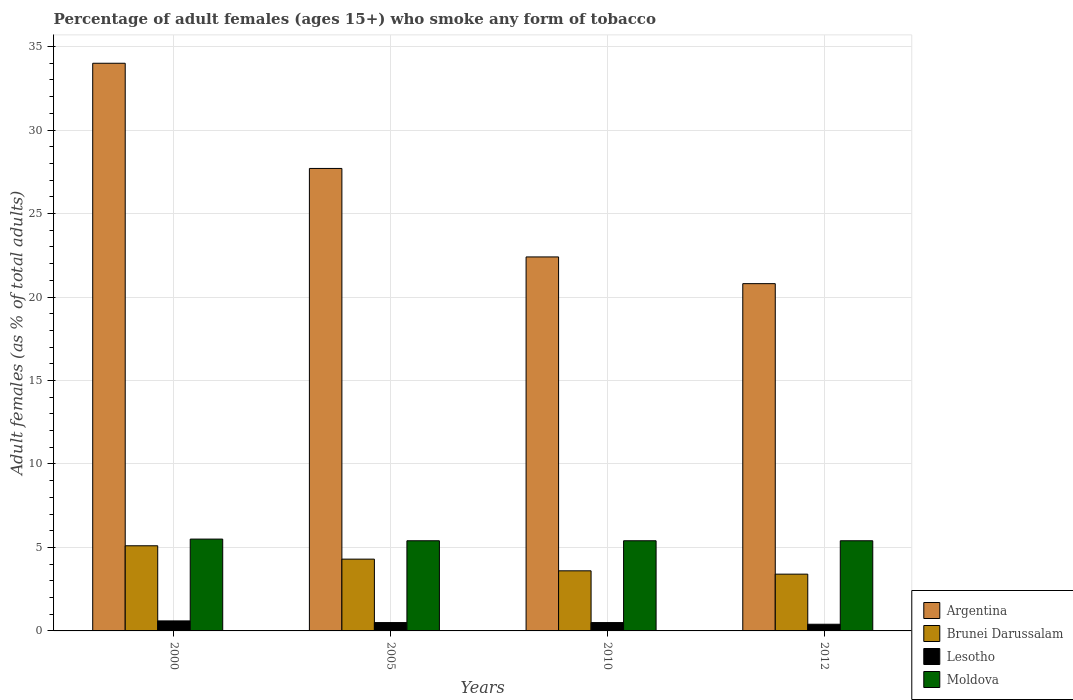How many groups of bars are there?
Give a very brief answer. 4. How many bars are there on the 4th tick from the left?
Provide a succinct answer. 4. How many bars are there on the 3rd tick from the right?
Your answer should be very brief. 4. What is the label of the 1st group of bars from the left?
Your answer should be compact. 2000. In how many cases, is the number of bars for a given year not equal to the number of legend labels?
Offer a very short reply. 0. What is the percentage of adult females who smoke in Argentina in 2012?
Give a very brief answer. 20.8. In which year was the percentage of adult females who smoke in Argentina maximum?
Your answer should be compact. 2000. What is the total percentage of adult females who smoke in Lesotho in the graph?
Provide a short and direct response. 2. What is the difference between the percentage of adult females who smoke in Brunei Darussalam in 2000 and that in 2010?
Your answer should be compact. 1.5. What is the difference between the percentage of adult females who smoke in Argentina in 2010 and the percentage of adult females who smoke in Lesotho in 2005?
Your answer should be compact. 21.9. What is the average percentage of adult females who smoke in Brunei Darussalam per year?
Provide a succinct answer. 4.1. In the year 2000, what is the difference between the percentage of adult females who smoke in Argentina and percentage of adult females who smoke in Brunei Darussalam?
Your response must be concise. 28.9. In how many years, is the percentage of adult females who smoke in Brunei Darussalam greater than 11 %?
Your answer should be very brief. 0. What is the ratio of the percentage of adult females who smoke in Brunei Darussalam in 2000 to that in 2010?
Provide a succinct answer. 1.42. Is the percentage of adult females who smoke in Lesotho in 2005 less than that in 2010?
Give a very brief answer. No. Is the difference between the percentage of adult females who smoke in Argentina in 2005 and 2012 greater than the difference between the percentage of adult females who smoke in Brunei Darussalam in 2005 and 2012?
Offer a very short reply. Yes. What is the difference between the highest and the second highest percentage of adult females who smoke in Lesotho?
Make the answer very short. 0.1. What is the difference between the highest and the lowest percentage of adult females who smoke in Brunei Darussalam?
Provide a short and direct response. 1.7. Is it the case that in every year, the sum of the percentage of adult females who smoke in Moldova and percentage of adult females who smoke in Brunei Darussalam is greater than the sum of percentage of adult females who smoke in Lesotho and percentage of adult females who smoke in Argentina?
Make the answer very short. Yes. What does the 2nd bar from the left in 2005 represents?
Offer a very short reply. Brunei Darussalam. What does the 2nd bar from the right in 2005 represents?
Offer a terse response. Lesotho. Is it the case that in every year, the sum of the percentage of adult females who smoke in Argentina and percentage of adult females who smoke in Moldova is greater than the percentage of adult females who smoke in Lesotho?
Offer a terse response. Yes. How many years are there in the graph?
Keep it short and to the point. 4. Does the graph contain any zero values?
Keep it short and to the point. No. Does the graph contain grids?
Provide a succinct answer. Yes. Where does the legend appear in the graph?
Your answer should be very brief. Bottom right. How are the legend labels stacked?
Your answer should be very brief. Vertical. What is the title of the graph?
Ensure brevity in your answer.  Percentage of adult females (ages 15+) who smoke any form of tobacco. What is the label or title of the Y-axis?
Offer a very short reply. Adult females (as % of total adults). What is the Adult females (as % of total adults) of Argentina in 2005?
Provide a short and direct response. 27.7. What is the Adult females (as % of total adults) in Argentina in 2010?
Your response must be concise. 22.4. What is the Adult females (as % of total adults) in Brunei Darussalam in 2010?
Your answer should be very brief. 3.6. What is the Adult females (as % of total adults) of Argentina in 2012?
Offer a very short reply. 20.8. Across all years, what is the maximum Adult females (as % of total adults) in Argentina?
Provide a succinct answer. 34. Across all years, what is the maximum Adult females (as % of total adults) in Brunei Darussalam?
Offer a very short reply. 5.1. Across all years, what is the maximum Adult females (as % of total adults) of Moldova?
Offer a terse response. 5.5. Across all years, what is the minimum Adult females (as % of total adults) of Argentina?
Make the answer very short. 20.8. Across all years, what is the minimum Adult females (as % of total adults) in Brunei Darussalam?
Make the answer very short. 3.4. Across all years, what is the minimum Adult females (as % of total adults) of Lesotho?
Give a very brief answer. 0.4. Across all years, what is the minimum Adult females (as % of total adults) in Moldova?
Ensure brevity in your answer.  5.4. What is the total Adult females (as % of total adults) in Argentina in the graph?
Make the answer very short. 104.9. What is the total Adult females (as % of total adults) of Brunei Darussalam in the graph?
Offer a terse response. 16.4. What is the total Adult females (as % of total adults) of Moldova in the graph?
Provide a short and direct response. 21.7. What is the difference between the Adult females (as % of total adults) of Argentina in 2000 and that in 2005?
Offer a terse response. 6.3. What is the difference between the Adult females (as % of total adults) of Argentina in 2000 and that in 2010?
Your response must be concise. 11.6. What is the difference between the Adult females (as % of total adults) of Brunei Darussalam in 2000 and that in 2010?
Offer a terse response. 1.5. What is the difference between the Adult females (as % of total adults) of Lesotho in 2000 and that in 2012?
Your response must be concise. 0.2. What is the difference between the Adult females (as % of total adults) of Moldova in 2000 and that in 2012?
Make the answer very short. 0.1. What is the difference between the Adult females (as % of total adults) in Brunei Darussalam in 2005 and that in 2010?
Offer a very short reply. 0.7. What is the difference between the Adult females (as % of total adults) of Lesotho in 2005 and that in 2010?
Your answer should be compact. 0. What is the difference between the Adult females (as % of total adults) of Brunei Darussalam in 2005 and that in 2012?
Make the answer very short. 0.9. What is the difference between the Adult females (as % of total adults) in Moldova in 2005 and that in 2012?
Give a very brief answer. 0. What is the difference between the Adult females (as % of total adults) of Brunei Darussalam in 2010 and that in 2012?
Offer a very short reply. 0.2. What is the difference between the Adult females (as % of total adults) in Lesotho in 2010 and that in 2012?
Ensure brevity in your answer.  0.1. What is the difference between the Adult females (as % of total adults) of Argentina in 2000 and the Adult females (as % of total adults) of Brunei Darussalam in 2005?
Keep it short and to the point. 29.7. What is the difference between the Adult females (as % of total adults) of Argentina in 2000 and the Adult females (as % of total adults) of Lesotho in 2005?
Give a very brief answer. 33.5. What is the difference between the Adult females (as % of total adults) of Argentina in 2000 and the Adult females (as % of total adults) of Moldova in 2005?
Offer a terse response. 28.6. What is the difference between the Adult females (as % of total adults) in Brunei Darussalam in 2000 and the Adult females (as % of total adults) in Lesotho in 2005?
Ensure brevity in your answer.  4.6. What is the difference between the Adult females (as % of total adults) in Brunei Darussalam in 2000 and the Adult females (as % of total adults) in Moldova in 2005?
Offer a terse response. -0.3. What is the difference between the Adult females (as % of total adults) in Argentina in 2000 and the Adult females (as % of total adults) in Brunei Darussalam in 2010?
Provide a succinct answer. 30.4. What is the difference between the Adult females (as % of total adults) of Argentina in 2000 and the Adult females (as % of total adults) of Lesotho in 2010?
Your response must be concise. 33.5. What is the difference between the Adult females (as % of total adults) of Argentina in 2000 and the Adult females (as % of total adults) of Moldova in 2010?
Make the answer very short. 28.6. What is the difference between the Adult females (as % of total adults) of Brunei Darussalam in 2000 and the Adult females (as % of total adults) of Lesotho in 2010?
Your answer should be very brief. 4.6. What is the difference between the Adult females (as % of total adults) of Argentina in 2000 and the Adult females (as % of total adults) of Brunei Darussalam in 2012?
Your response must be concise. 30.6. What is the difference between the Adult females (as % of total adults) in Argentina in 2000 and the Adult females (as % of total adults) in Lesotho in 2012?
Provide a short and direct response. 33.6. What is the difference between the Adult females (as % of total adults) of Argentina in 2000 and the Adult females (as % of total adults) of Moldova in 2012?
Provide a short and direct response. 28.6. What is the difference between the Adult females (as % of total adults) in Brunei Darussalam in 2000 and the Adult females (as % of total adults) in Moldova in 2012?
Keep it short and to the point. -0.3. What is the difference between the Adult females (as % of total adults) in Lesotho in 2000 and the Adult females (as % of total adults) in Moldova in 2012?
Keep it short and to the point. -4.8. What is the difference between the Adult females (as % of total adults) of Argentina in 2005 and the Adult females (as % of total adults) of Brunei Darussalam in 2010?
Offer a terse response. 24.1. What is the difference between the Adult females (as % of total adults) of Argentina in 2005 and the Adult females (as % of total adults) of Lesotho in 2010?
Your response must be concise. 27.2. What is the difference between the Adult females (as % of total adults) in Argentina in 2005 and the Adult females (as % of total adults) in Moldova in 2010?
Give a very brief answer. 22.3. What is the difference between the Adult females (as % of total adults) in Brunei Darussalam in 2005 and the Adult females (as % of total adults) in Lesotho in 2010?
Keep it short and to the point. 3.8. What is the difference between the Adult females (as % of total adults) in Brunei Darussalam in 2005 and the Adult females (as % of total adults) in Moldova in 2010?
Keep it short and to the point. -1.1. What is the difference between the Adult females (as % of total adults) in Argentina in 2005 and the Adult females (as % of total adults) in Brunei Darussalam in 2012?
Offer a very short reply. 24.3. What is the difference between the Adult females (as % of total adults) of Argentina in 2005 and the Adult females (as % of total adults) of Lesotho in 2012?
Ensure brevity in your answer.  27.3. What is the difference between the Adult females (as % of total adults) of Argentina in 2005 and the Adult females (as % of total adults) of Moldova in 2012?
Give a very brief answer. 22.3. What is the difference between the Adult females (as % of total adults) of Brunei Darussalam in 2005 and the Adult females (as % of total adults) of Moldova in 2012?
Provide a short and direct response. -1.1. What is the difference between the Adult females (as % of total adults) of Argentina in 2010 and the Adult females (as % of total adults) of Brunei Darussalam in 2012?
Provide a succinct answer. 19. What is the difference between the Adult females (as % of total adults) of Argentina in 2010 and the Adult females (as % of total adults) of Moldova in 2012?
Give a very brief answer. 17. What is the difference between the Adult females (as % of total adults) in Brunei Darussalam in 2010 and the Adult females (as % of total adults) in Lesotho in 2012?
Your answer should be compact. 3.2. What is the average Adult females (as % of total adults) in Argentina per year?
Offer a very short reply. 26.23. What is the average Adult females (as % of total adults) in Brunei Darussalam per year?
Your answer should be compact. 4.1. What is the average Adult females (as % of total adults) in Moldova per year?
Make the answer very short. 5.42. In the year 2000, what is the difference between the Adult females (as % of total adults) of Argentina and Adult females (as % of total adults) of Brunei Darussalam?
Make the answer very short. 28.9. In the year 2000, what is the difference between the Adult females (as % of total adults) of Argentina and Adult females (as % of total adults) of Lesotho?
Your response must be concise. 33.4. In the year 2000, what is the difference between the Adult females (as % of total adults) in Argentina and Adult females (as % of total adults) in Moldova?
Your answer should be very brief. 28.5. In the year 2000, what is the difference between the Adult females (as % of total adults) in Brunei Darussalam and Adult females (as % of total adults) in Lesotho?
Keep it short and to the point. 4.5. In the year 2000, what is the difference between the Adult females (as % of total adults) of Lesotho and Adult females (as % of total adults) of Moldova?
Give a very brief answer. -4.9. In the year 2005, what is the difference between the Adult females (as % of total adults) in Argentina and Adult females (as % of total adults) in Brunei Darussalam?
Offer a terse response. 23.4. In the year 2005, what is the difference between the Adult females (as % of total adults) of Argentina and Adult females (as % of total adults) of Lesotho?
Make the answer very short. 27.2. In the year 2005, what is the difference between the Adult females (as % of total adults) in Argentina and Adult females (as % of total adults) in Moldova?
Give a very brief answer. 22.3. In the year 2005, what is the difference between the Adult females (as % of total adults) of Brunei Darussalam and Adult females (as % of total adults) of Lesotho?
Provide a succinct answer. 3.8. In the year 2005, what is the difference between the Adult females (as % of total adults) in Brunei Darussalam and Adult females (as % of total adults) in Moldova?
Give a very brief answer. -1.1. In the year 2005, what is the difference between the Adult females (as % of total adults) in Lesotho and Adult females (as % of total adults) in Moldova?
Make the answer very short. -4.9. In the year 2010, what is the difference between the Adult females (as % of total adults) of Argentina and Adult females (as % of total adults) of Lesotho?
Ensure brevity in your answer.  21.9. In the year 2010, what is the difference between the Adult females (as % of total adults) in Argentina and Adult females (as % of total adults) in Moldova?
Your answer should be compact. 17. In the year 2010, what is the difference between the Adult females (as % of total adults) in Brunei Darussalam and Adult females (as % of total adults) in Lesotho?
Your response must be concise. 3.1. In the year 2010, what is the difference between the Adult females (as % of total adults) in Brunei Darussalam and Adult females (as % of total adults) in Moldova?
Provide a succinct answer. -1.8. In the year 2012, what is the difference between the Adult females (as % of total adults) in Argentina and Adult females (as % of total adults) in Lesotho?
Keep it short and to the point. 20.4. In the year 2012, what is the difference between the Adult females (as % of total adults) of Brunei Darussalam and Adult females (as % of total adults) of Moldova?
Ensure brevity in your answer.  -2. In the year 2012, what is the difference between the Adult females (as % of total adults) in Lesotho and Adult females (as % of total adults) in Moldova?
Ensure brevity in your answer.  -5. What is the ratio of the Adult females (as % of total adults) of Argentina in 2000 to that in 2005?
Provide a succinct answer. 1.23. What is the ratio of the Adult females (as % of total adults) in Brunei Darussalam in 2000 to that in 2005?
Keep it short and to the point. 1.19. What is the ratio of the Adult females (as % of total adults) of Moldova in 2000 to that in 2005?
Keep it short and to the point. 1.02. What is the ratio of the Adult females (as % of total adults) in Argentina in 2000 to that in 2010?
Provide a succinct answer. 1.52. What is the ratio of the Adult females (as % of total adults) in Brunei Darussalam in 2000 to that in 2010?
Give a very brief answer. 1.42. What is the ratio of the Adult females (as % of total adults) of Moldova in 2000 to that in 2010?
Offer a very short reply. 1.02. What is the ratio of the Adult females (as % of total adults) in Argentina in 2000 to that in 2012?
Provide a short and direct response. 1.63. What is the ratio of the Adult females (as % of total adults) in Moldova in 2000 to that in 2012?
Give a very brief answer. 1.02. What is the ratio of the Adult females (as % of total adults) of Argentina in 2005 to that in 2010?
Make the answer very short. 1.24. What is the ratio of the Adult females (as % of total adults) in Brunei Darussalam in 2005 to that in 2010?
Give a very brief answer. 1.19. What is the ratio of the Adult females (as % of total adults) in Lesotho in 2005 to that in 2010?
Provide a succinct answer. 1. What is the ratio of the Adult females (as % of total adults) in Moldova in 2005 to that in 2010?
Offer a terse response. 1. What is the ratio of the Adult females (as % of total adults) of Argentina in 2005 to that in 2012?
Your answer should be compact. 1.33. What is the ratio of the Adult females (as % of total adults) of Brunei Darussalam in 2005 to that in 2012?
Offer a terse response. 1.26. What is the ratio of the Adult females (as % of total adults) in Lesotho in 2005 to that in 2012?
Offer a terse response. 1.25. What is the ratio of the Adult females (as % of total adults) of Moldova in 2005 to that in 2012?
Keep it short and to the point. 1. What is the ratio of the Adult females (as % of total adults) in Argentina in 2010 to that in 2012?
Give a very brief answer. 1.08. What is the ratio of the Adult females (as % of total adults) in Brunei Darussalam in 2010 to that in 2012?
Keep it short and to the point. 1.06. What is the ratio of the Adult females (as % of total adults) of Lesotho in 2010 to that in 2012?
Make the answer very short. 1.25. What is the ratio of the Adult females (as % of total adults) of Moldova in 2010 to that in 2012?
Your response must be concise. 1. What is the difference between the highest and the second highest Adult females (as % of total adults) in Argentina?
Your response must be concise. 6.3. What is the difference between the highest and the second highest Adult females (as % of total adults) of Brunei Darussalam?
Your answer should be very brief. 0.8. What is the difference between the highest and the second highest Adult females (as % of total adults) of Lesotho?
Your answer should be very brief. 0.1. What is the difference between the highest and the second highest Adult females (as % of total adults) of Moldova?
Give a very brief answer. 0.1. What is the difference between the highest and the lowest Adult females (as % of total adults) in Argentina?
Your answer should be compact. 13.2. What is the difference between the highest and the lowest Adult females (as % of total adults) of Brunei Darussalam?
Provide a short and direct response. 1.7. 